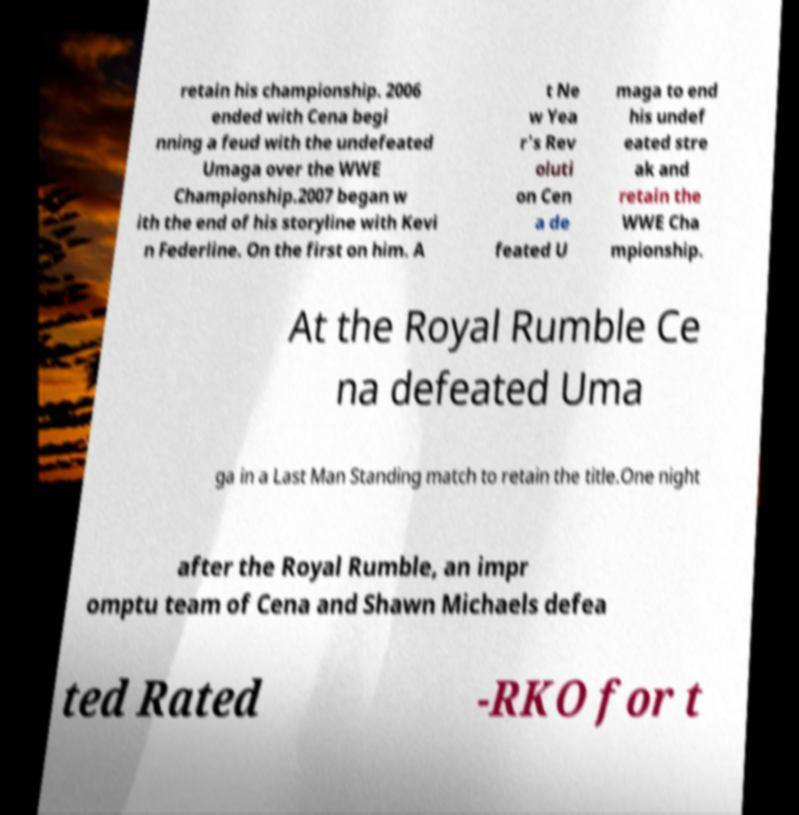There's text embedded in this image that I need extracted. Can you transcribe it verbatim? retain his championship. 2006 ended with Cena begi nning a feud with the undefeated Umaga over the WWE Championship.2007 began w ith the end of his storyline with Kevi n Federline. On the first on him. A t Ne w Yea r's Rev oluti on Cen a de feated U maga to end his undef eated stre ak and retain the WWE Cha mpionship. At the Royal Rumble Ce na defeated Uma ga in a Last Man Standing match to retain the title.One night after the Royal Rumble, an impr omptu team of Cena and Shawn Michaels defea ted Rated -RKO for t 